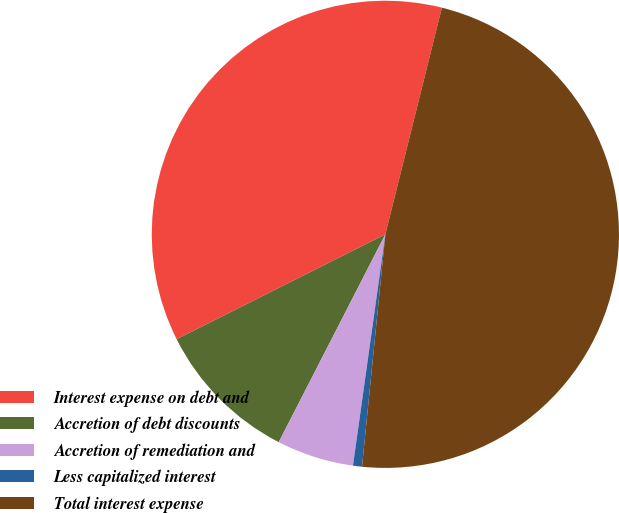<chart> <loc_0><loc_0><loc_500><loc_500><pie_chart><fcel>Interest expense on debt and<fcel>Accretion of debt discounts<fcel>Accretion of remediation and<fcel>Less capitalized interest<fcel>Total interest expense<nl><fcel>36.3%<fcel>10.04%<fcel>5.33%<fcel>0.62%<fcel>47.7%<nl></chart> 